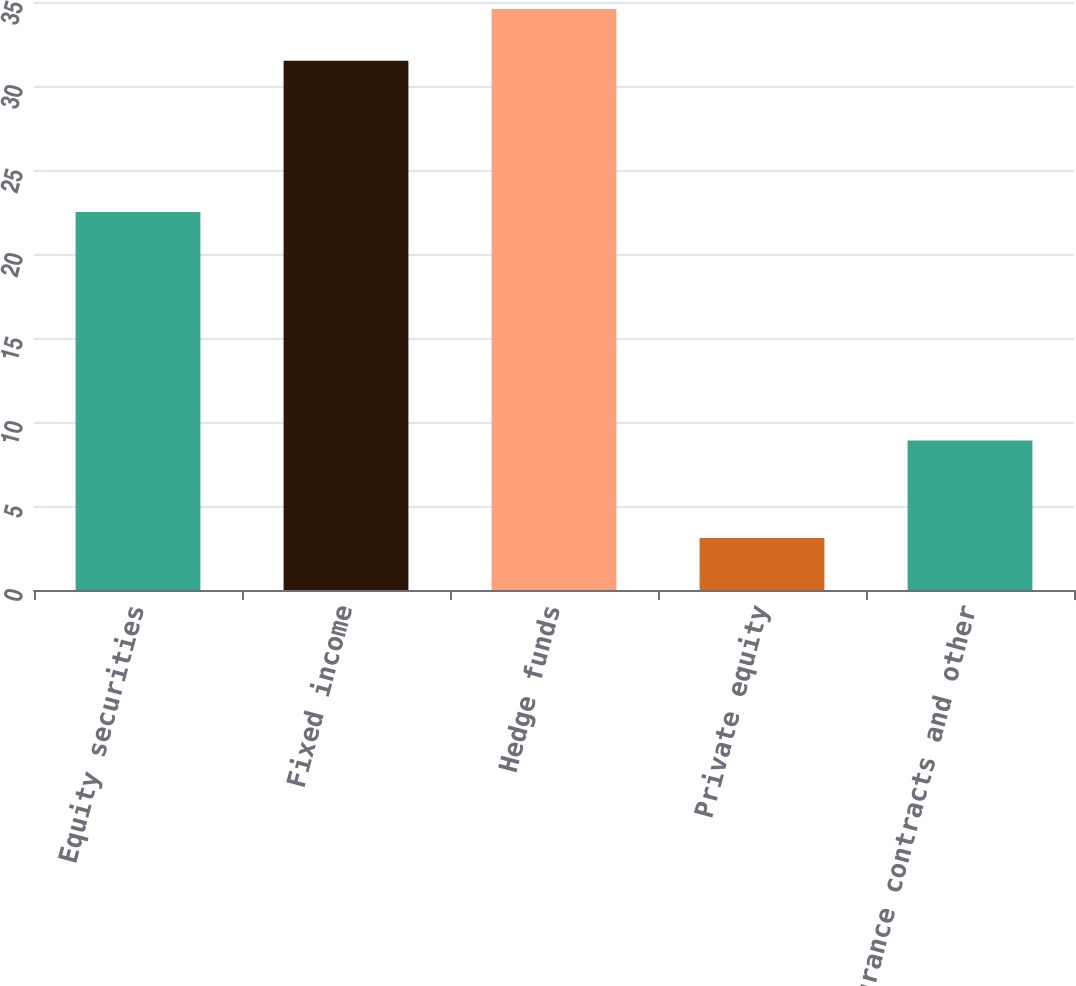<chart> <loc_0><loc_0><loc_500><loc_500><bar_chart><fcel>Equity securities<fcel>Fixed income<fcel>Hedge funds<fcel>Private equity<fcel>Insurance contracts and other<nl><fcel>22.5<fcel>31.5<fcel>34.59<fcel>3.1<fcel>8.9<nl></chart> 